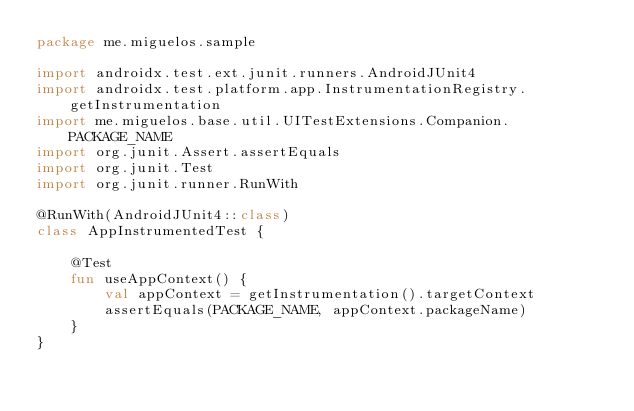<code> <loc_0><loc_0><loc_500><loc_500><_Kotlin_>package me.miguelos.sample

import androidx.test.ext.junit.runners.AndroidJUnit4
import androidx.test.platform.app.InstrumentationRegistry.getInstrumentation
import me.miguelos.base.util.UITestExtensions.Companion.PACKAGE_NAME
import org.junit.Assert.assertEquals
import org.junit.Test
import org.junit.runner.RunWith

@RunWith(AndroidJUnit4::class)
class AppInstrumentedTest {

    @Test
    fun useAppContext() {
        val appContext = getInstrumentation().targetContext
        assertEquals(PACKAGE_NAME, appContext.packageName)
    }
}
</code> 